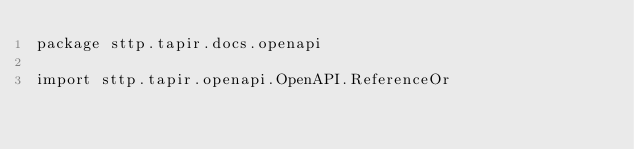Convert code to text. <code><loc_0><loc_0><loc_500><loc_500><_Scala_>package sttp.tapir.docs.openapi

import sttp.tapir.openapi.OpenAPI.ReferenceOr</code> 